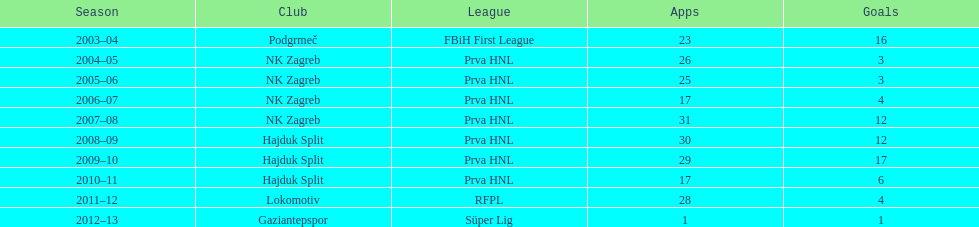Which club names had over 15 goals scored in one season? Podgrmeč, Hajduk Split. 